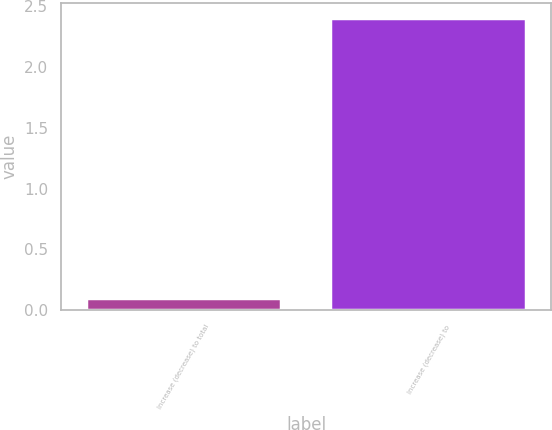Convert chart. <chart><loc_0><loc_0><loc_500><loc_500><bar_chart><fcel>Increase (decrease) to total<fcel>Increase (decrease) to<nl><fcel>0.1<fcel>2.4<nl></chart> 